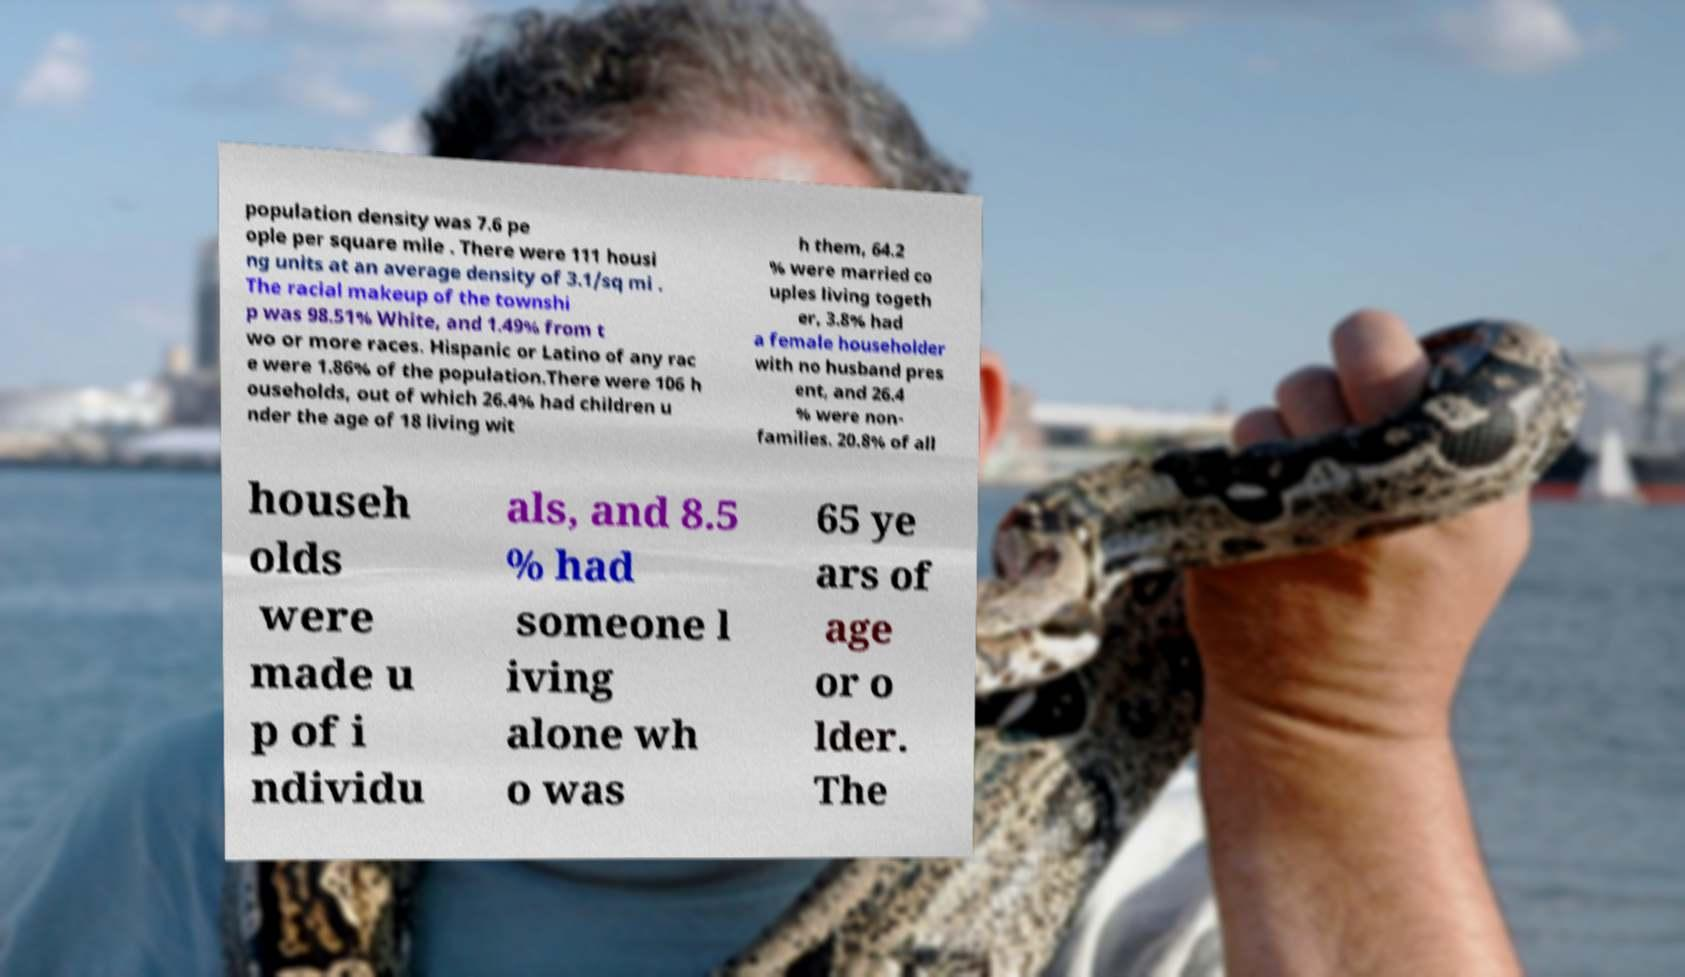Please identify and transcribe the text found in this image. population density was 7.6 pe ople per square mile . There were 111 housi ng units at an average density of 3.1/sq mi . The racial makeup of the townshi p was 98.51% White, and 1.49% from t wo or more races. Hispanic or Latino of any rac e were 1.86% of the population.There were 106 h ouseholds, out of which 26.4% had children u nder the age of 18 living wit h them, 64.2 % were married co uples living togeth er, 3.8% had a female householder with no husband pres ent, and 26.4 % were non- families. 20.8% of all househ olds were made u p of i ndividu als, and 8.5 % had someone l iving alone wh o was 65 ye ars of age or o lder. The 